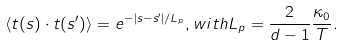<formula> <loc_0><loc_0><loc_500><loc_500>\langle { t } ( s ) \cdot { t } ( s ^ { \prime } ) \rangle = e ^ { - | s - s ^ { \prime } | / L _ { p } } , w i t h L _ { p } = \frac { 2 } { d - 1 } \frac { \kappa _ { 0 } } { T } .</formula> 